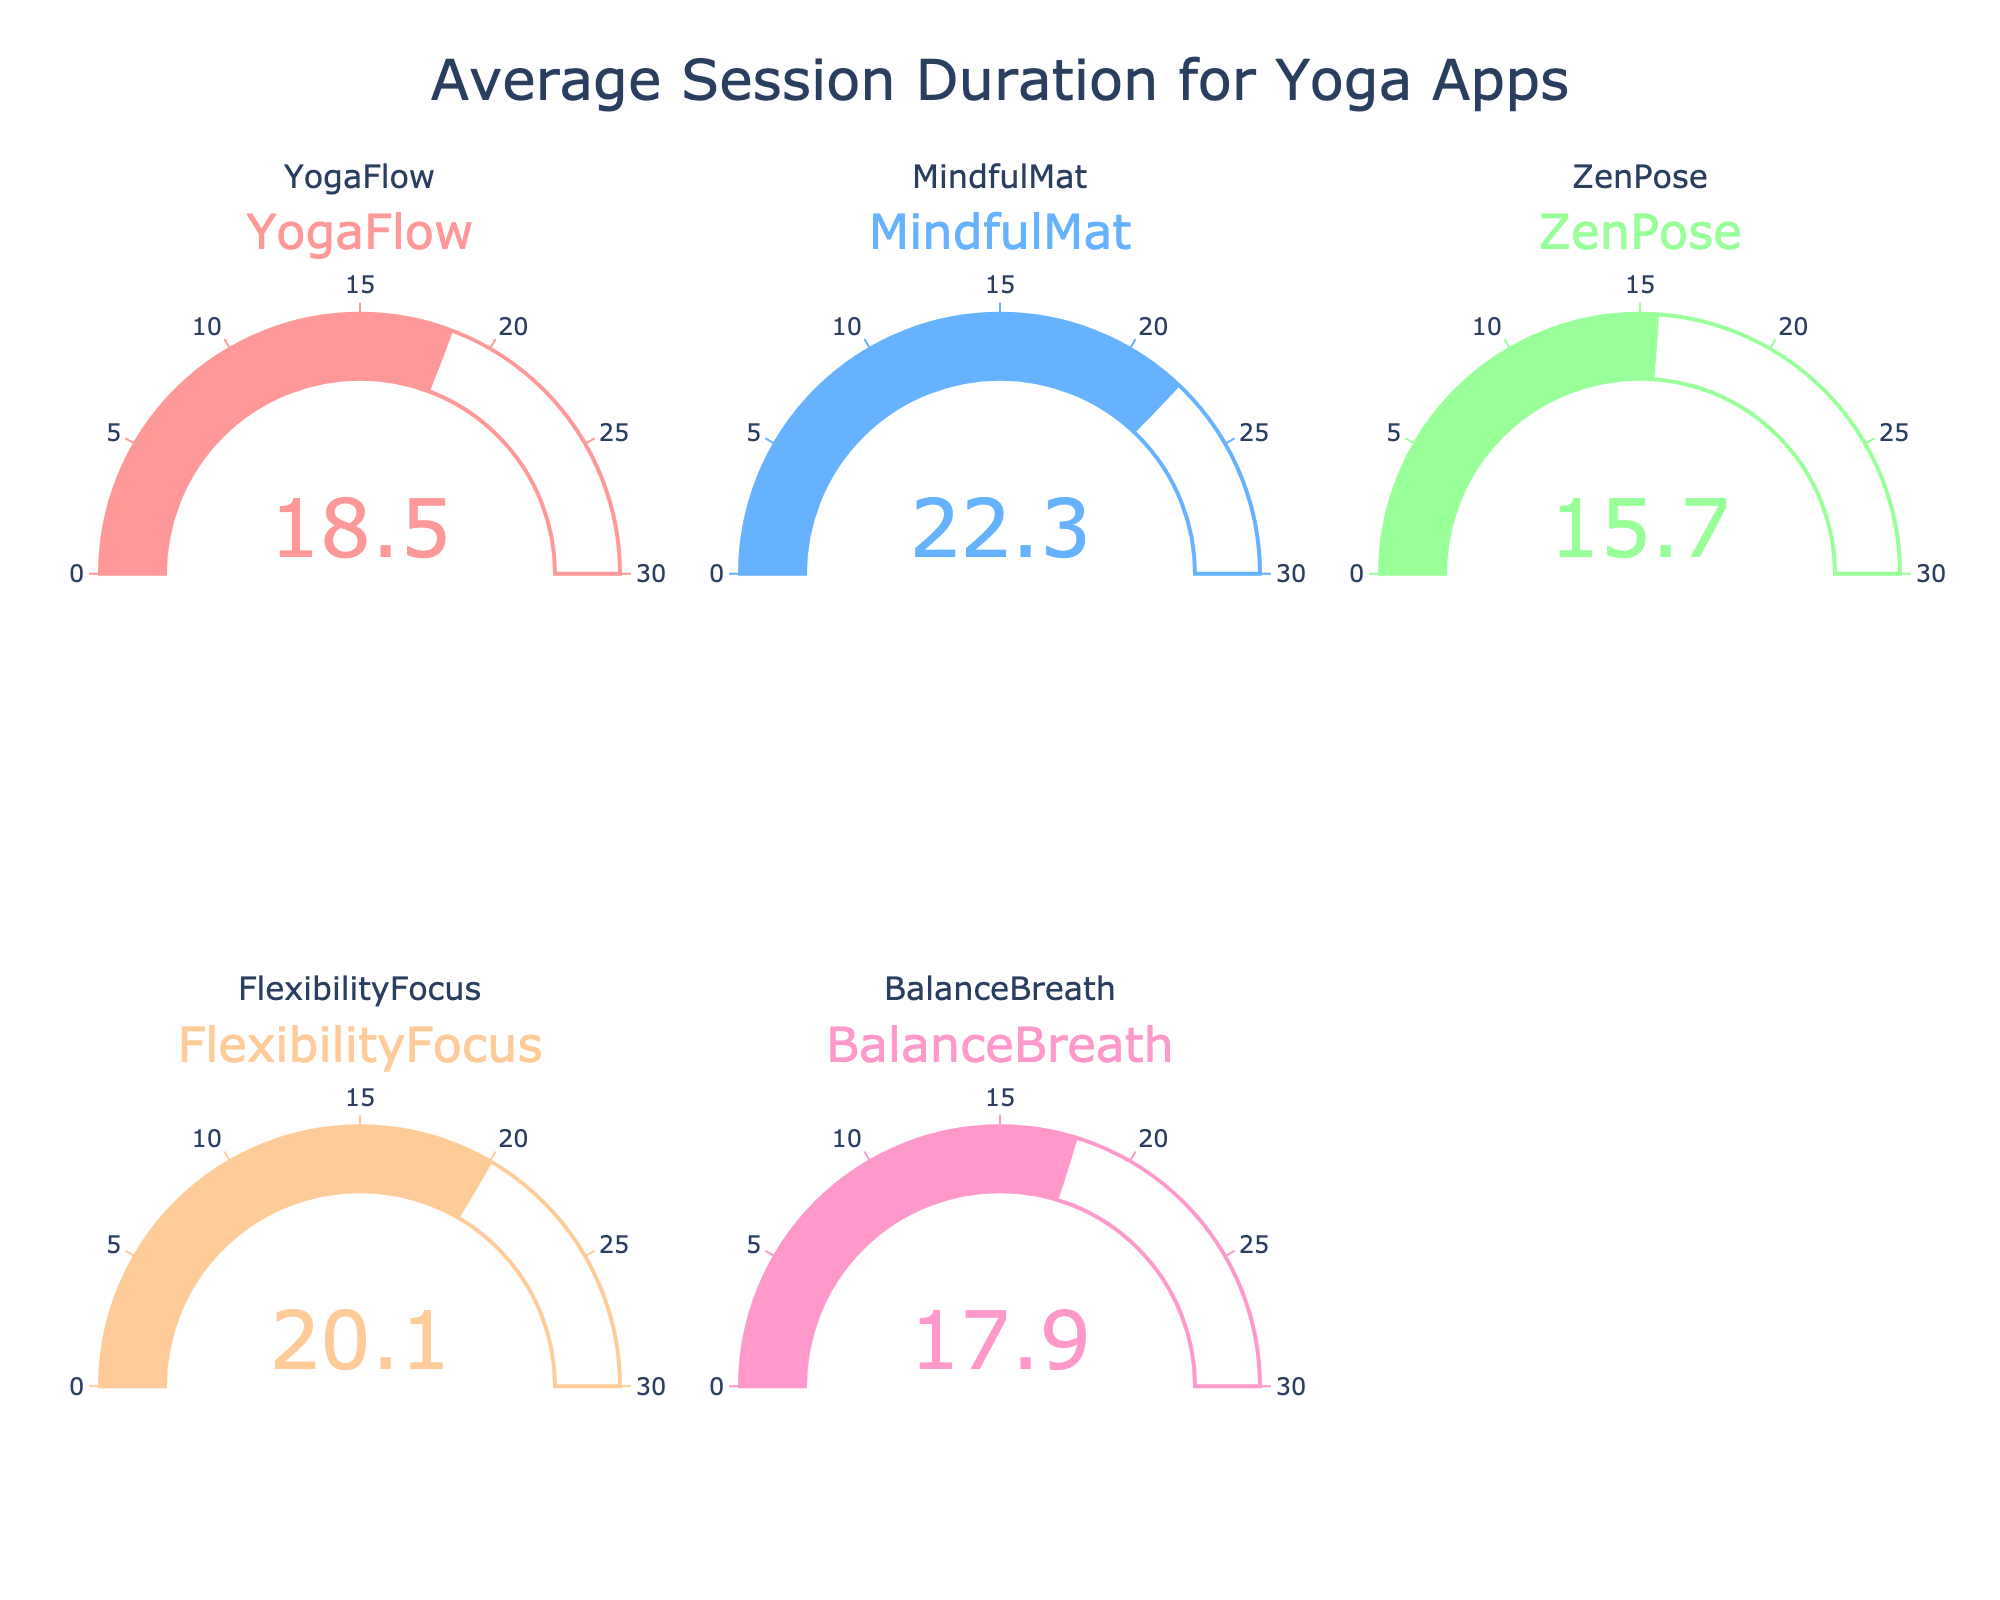What is the title of the figure? The title of the figure is displayed prominently at the top of the figure. It reads 'Average Session Duration for Yoga Apps.' A title usually provides context about what the figure represents.
Answer: Average Session Duration for Yoga Apps How many apps are shown in the figure? The figure includes one gauge chart for each app. Counting the gauge charts, we see there are five in total.
Answer: Five Which app has the longest average session duration? By observing the values displayed on each gauge, we see that the 'MindfulMat' app has an average session duration of 22.3 minutes, which is higher than all others.
Answer: MindfulMat What is the average session duration for 'ZenPose'? The gauge labeled 'ZenPose' shows the value 15.7. This indicates that the average session duration for 'ZenPose' is 15.7 minutes.
Answer: 15.7 minutes Which app has the shortest average session duration? Looking at all the gauges, the 'ZenPose' gauge shows the lowest value of 15.7 minutes among all listed apps.
Answer: ZenPose What is the difference in average session duration between 'YogaFlow' and 'BalanceBreath'? The gauge for 'YogaFlow' shows 18.5 minutes, and the gauge for 'BalanceBreath' shows 17.9 minutes. Subtracting these values, we get 18.5 - 17.9 = 0.6 minutes.
Answer: 0.6 minutes What is the combined average session duration of 'MindfulMat' and 'FlexibilityFocus'? The 'MindfulMat' and 'FlexibilityFocus' gauges show values of 22.3 and 20.1 minutes, respectively. Adding these together, we get 22.3 + 20.1 = 42.4 minutes.
Answer: 42.4 minutes Which app has an average session duration closest to 20 minutes? Looking at the gauges, 'FlexibilityFocus' with an average session duration of 20.1 minutes is closest to 20 minutes.
Answer: FlexibilityFocus How does the average session duration of 'BalanceBreath' compare to the median value of all apps? The values are 18.5, 22.3, 15.7, 20.1, and 17.9. Ordering them gives 15.7, 17.9, 18.5, 20.1, 22.3. The median value is 18.5. Comparing 'BalanceBreath' (17.9) to the median (18.5), 'BalanceBreath' is lower by 0.6 minutes.
Answer: Lower by 0.6 minutes Are there more apps with average session durations above or below 18 minutes? The durations are 18.5, 22.3, 15.7, 20.1, and 17.9 minutes. Counting values above 18 (18.5, 22.3, 20.1) gives us three apps. Counting values below 18 (15.7, 17.9) gives us two apps. Thus, more apps have durations above 18 minutes.
Answer: Above 